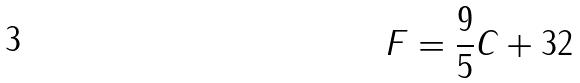<formula> <loc_0><loc_0><loc_500><loc_500>F = \frac { 9 } { 5 } C + 3 2</formula> 